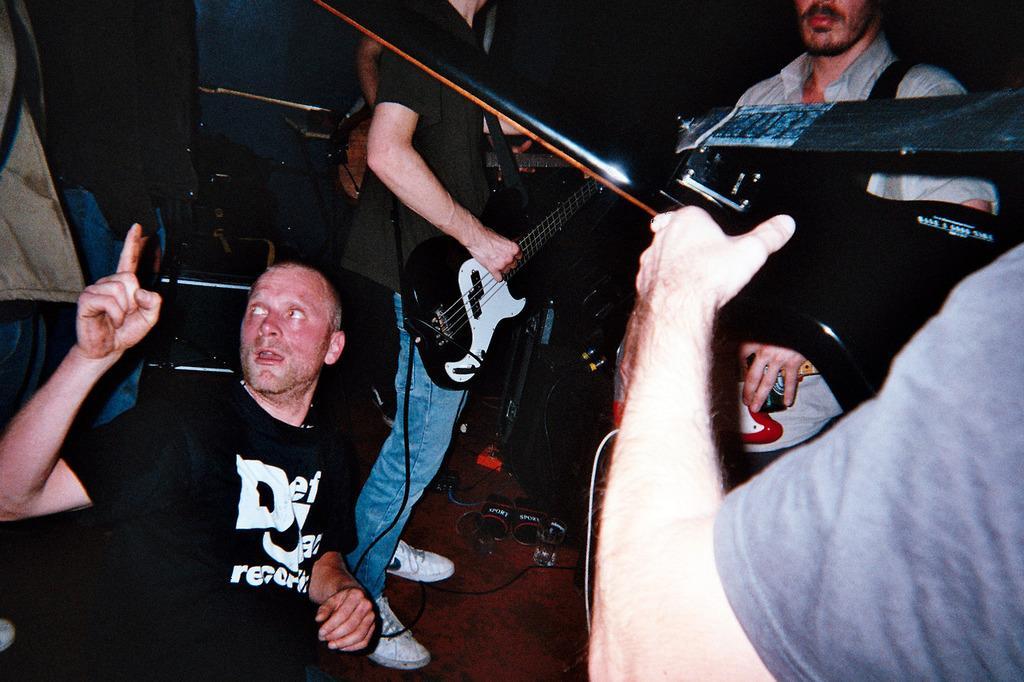Could you give a brief overview of what you see in this image? In this image there are group of people. In-front the man is holding a guitar. 